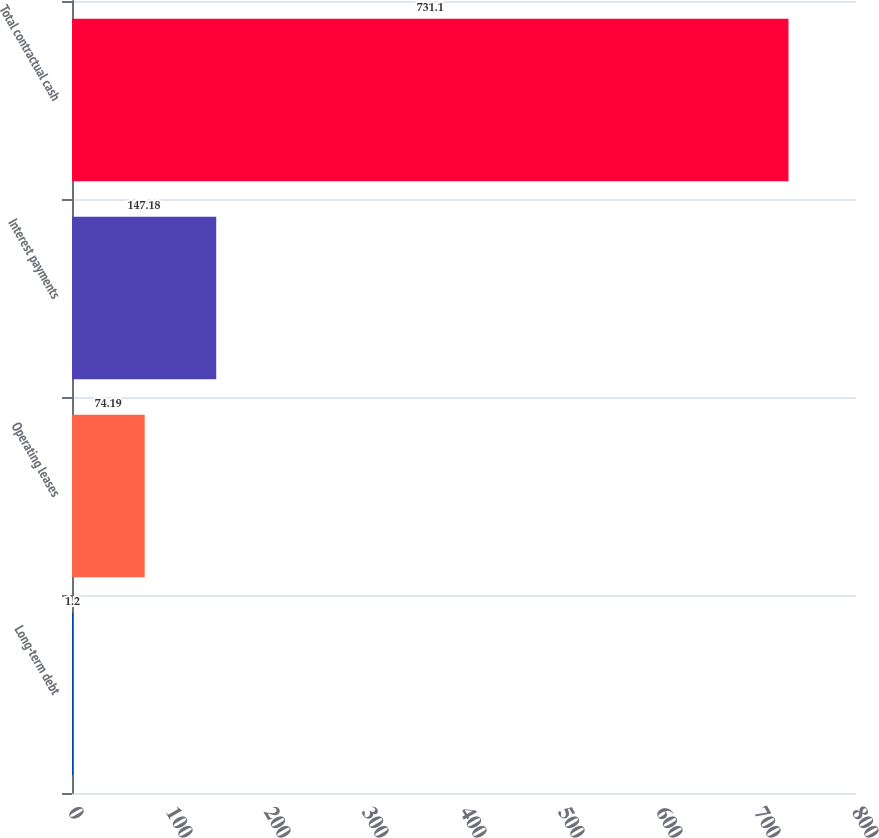Convert chart. <chart><loc_0><loc_0><loc_500><loc_500><bar_chart><fcel>Long-term debt<fcel>Operating leases<fcel>Interest payments<fcel>Total contractual cash<nl><fcel>1.2<fcel>74.19<fcel>147.18<fcel>731.1<nl></chart> 